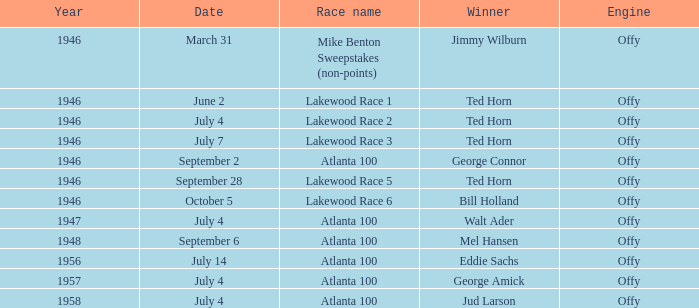Parse the full table. {'header': ['Year', 'Date', 'Race name', 'Winner', 'Engine'], 'rows': [['1946', 'March 31', 'Mike Benton Sweepstakes (non-points)', 'Jimmy Wilburn', 'Offy'], ['1946', 'June 2', 'Lakewood Race 1', 'Ted Horn', 'Offy'], ['1946', 'July 4', 'Lakewood Race 2', 'Ted Horn', 'Offy'], ['1946', 'July 7', 'Lakewood Race 3', 'Ted Horn', 'Offy'], ['1946', 'September 2', 'Atlanta 100', 'George Connor', 'Offy'], ['1946', 'September 28', 'Lakewood Race 5', 'Ted Horn', 'Offy'], ['1946', 'October 5', 'Lakewood Race 6', 'Bill Holland', 'Offy'], ['1947', 'July 4', 'Atlanta 100', 'Walt Ader', 'Offy'], ['1948', 'September 6', 'Atlanta 100', 'Mel Hansen', 'Offy'], ['1956', 'July 14', 'Atlanta 100', 'Eddie Sachs', 'Offy'], ['1957', 'July 4', 'Atlanta 100', 'George Amick', 'Offy'], ['1958', 'July 4', 'Atlanta 100', 'Jud Larson', 'Offy']]} Which race did Bill Holland win in 1946? Lakewood Race 6. 